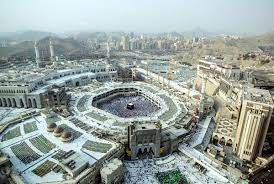What do you think is going on in this snapshot? The image captures a breathtaking aerial view of the Great Mosque of Mecca, the holiest site in Islam, during a moment of calm. The mosque's expansive white marble floors contrast sharply with the black, cube-shaped Kaaba at its center, a site of deep religious significance. Around the mosque, the urban sprawl of Mecca rises with a mix of modern high-rises and traditional architecture, bordered distantly by bare mountains. This powerful image not only showcases architectural beauty and urban development but also symbolizes the confluence of faith, history, and multiculturalism in one of the world’s most sacred spaces. 